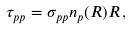Convert formula to latex. <formula><loc_0><loc_0><loc_500><loc_500>\tau _ { p p } = \sigma _ { p p } n _ { p } ( R ) R \, ,</formula> 